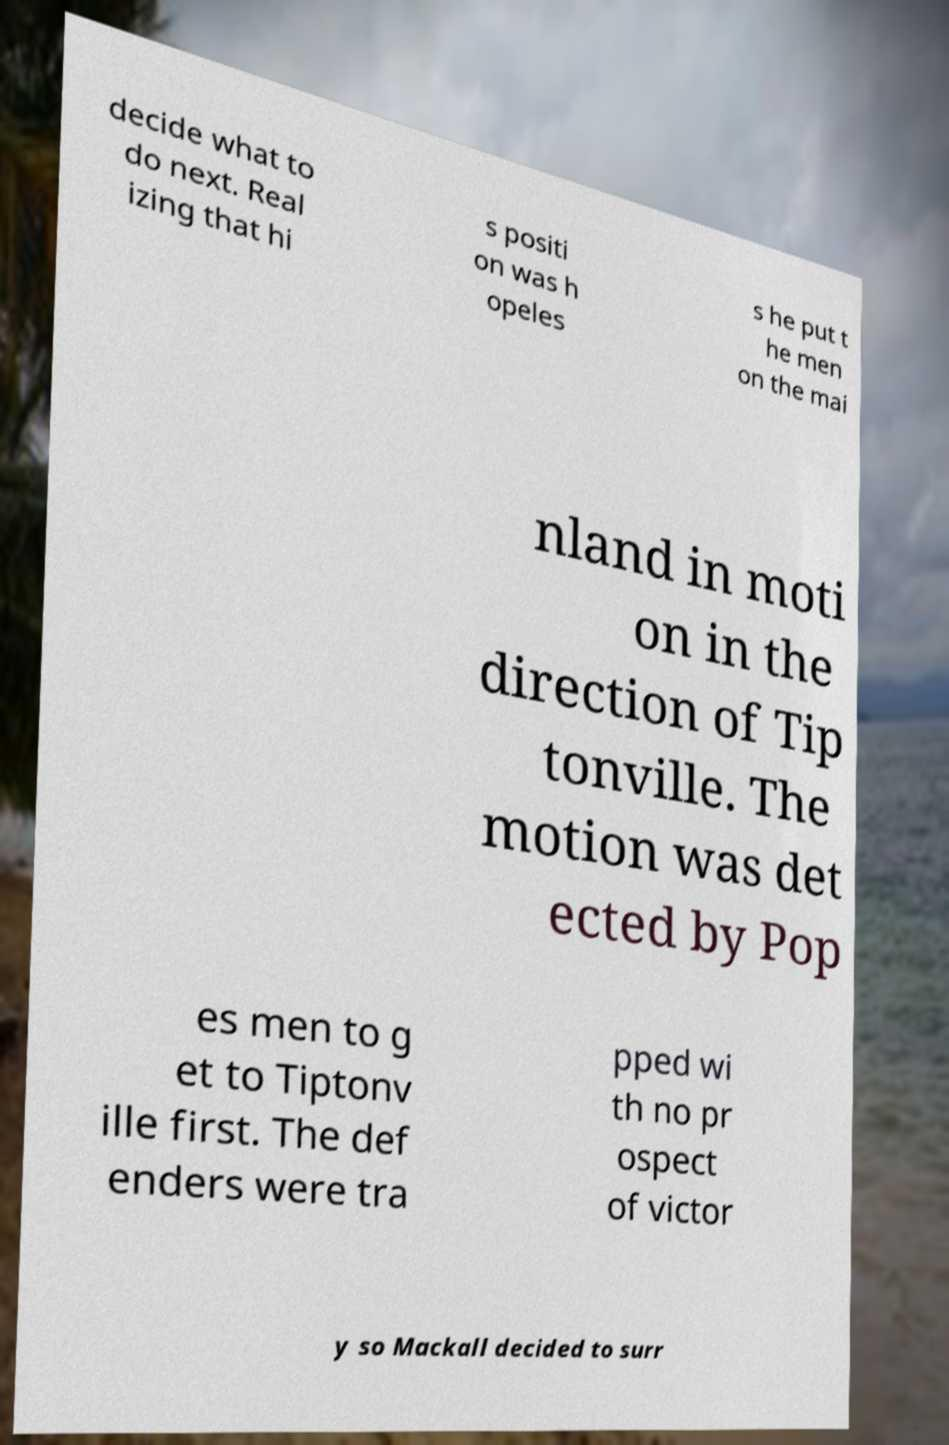Could you extract and type out the text from this image? decide what to do next. Real izing that hi s positi on was h opeles s he put t he men on the mai nland in moti on in the direction of Tip tonville. The motion was det ected by Pop es men to g et to Tiptonv ille first. The def enders were tra pped wi th no pr ospect of victor y so Mackall decided to surr 